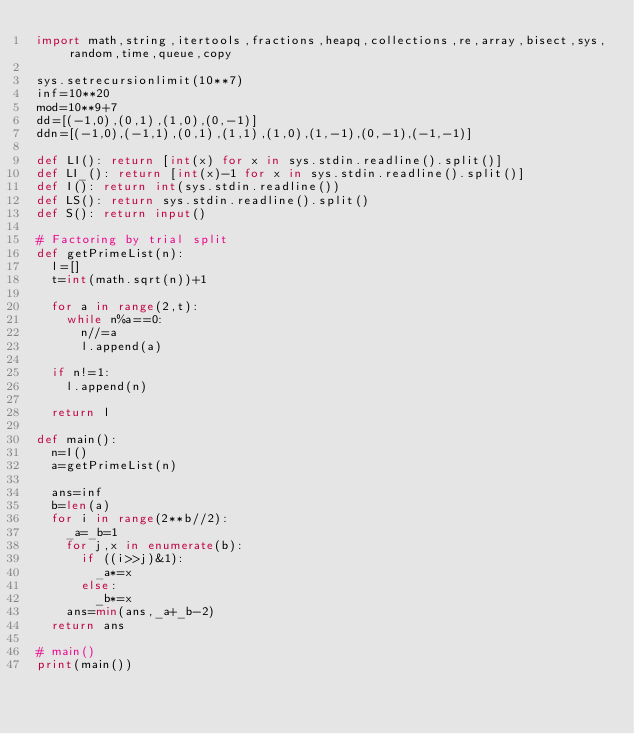<code> <loc_0><loc_0><loc_500><loc_500><_Python_>import math,string,itertools,fractions,heapq,collections,re,array,bisect,sys,random,time,queue,copy

sys.setrecursionlimit(10**7)
inf=10**20
mod=10**9+7
dd=[(-1,0),(0,1),(1,0),(0,-1)]
ddn=[(-1,0),(-1,1),(0,1),(1,1),(1,0),(1,-1),(0,-1),(-1,-1)]

def LI(): return [int(x) for x in sys.stdin.readline().split()]
def LI_(): return [int(x)-1 for x in sys.stdin.readline().split()]
def I(): return int(sys.stdin.readline())
def LS(): return sys.stdin.readline().split()
def S(): return input()

# Factoring by trial split
def getPrimeList(n):
  l=[]
  t=int(math.sqrt(n))+1
  
  for a in range(2,t):
    while n%a==0:
      n//=a
      l.append(a)
  
  if n!=1:
    l.append(n)
  
  return l

def main():
  n=I()
  a=getPrimeList(n)

  ans=inf
  b=len(a)
  for i in range(2**b//2):
    _a=_b=1
    for j,x in enumerate(b):
      if ((i>>j)&1):
        _a*=x
      else:
        _b*=x
    ans=min(ans,_a+_b-2)
  return ans

# main()
print(main())
</code> 